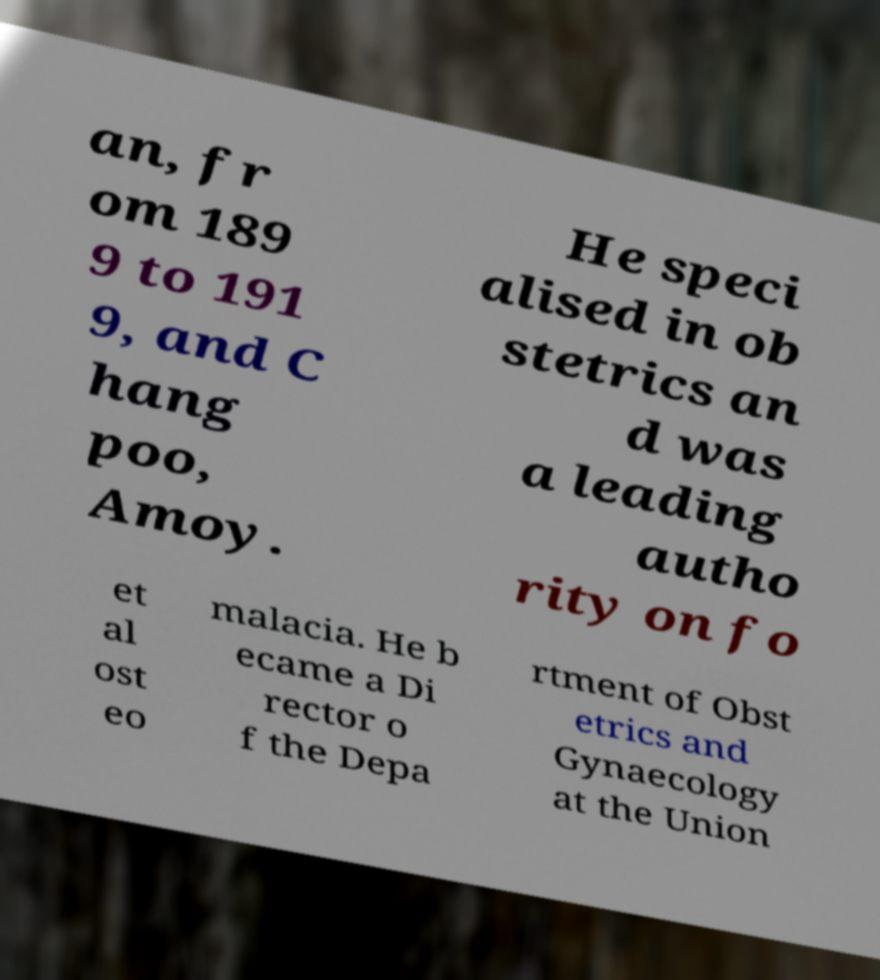Can you read and provide the text displayed in the image?This photo seems to have some interesting text. Can you extract and type it out for me? an, fr om 189 9 to 191 9, and C hang poo, Amoy. He speci alised in ob stetrics an d was a leading autho rity on fo et al ost eo malacia. He b ecame a Di rector o f the Depa rtment of Obst etrics and Gynaecology at the Union 